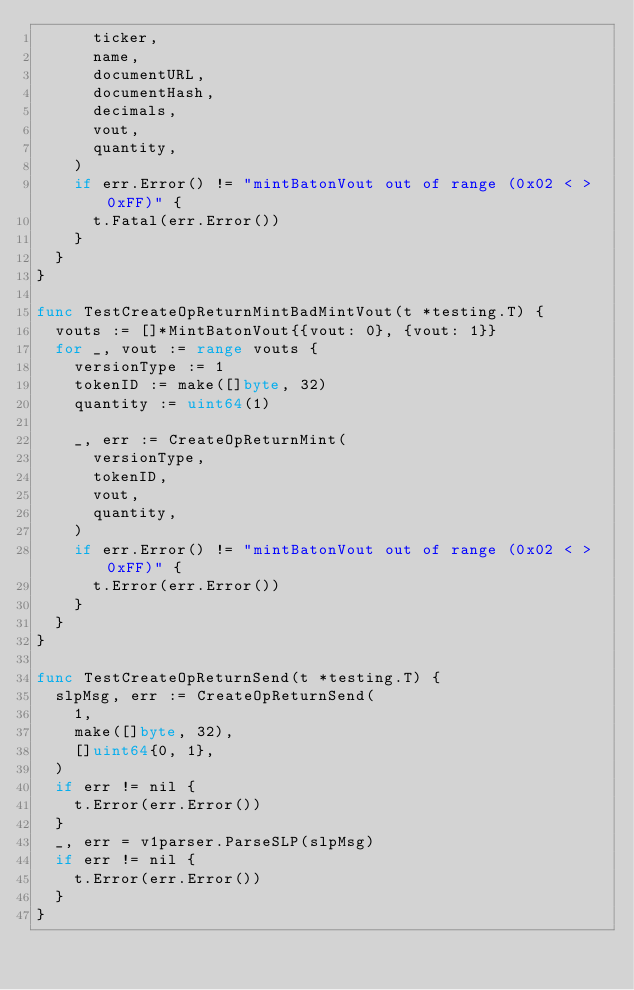Convert code to text. <code><loc_0><loc_0><loc_500><loc_500><_Go_>			ticker,
			name,
			documentURL,
			documentHash,
			decimals,
			vout,
			quantity,
		)
		if err.Error() != "mintBatonVout out of range (0x02 < > 0xFF)" {
			t.Fatal(err.Error())
		}
	}
}

func TestCreateOpReturnMintBadMintVout(t *testing.T) {
	vouts := []*MintBatonVout{{vout: 0}, {vout: 1}}
	for _, vout := range vouts {
		versionType := 1
		tokenID := make([]byte, 32)
		quantity := uint64(1)

		_, err := CreateOpReturnMint(
			versionType,
			tokenID,
			vout,
			quantity,
		)
		if err.Error() != "mintBatonVout out of range (0x02 < > 0xFF)" {
			t.Error(err.Error())
		}
	}
}

func TestCreateOpReturnSend(t *testing.T) {
	slpMsg, err := CreateOpReturnSend(
		1,
		make([]byte, 32),
		[]uint64{0, 1},
	)
	if err != nil {
		t.Error(err.Error())
	}
	_, err = v1parser.ParseSLP(slpMsg)
	if err != nil {
		t.Error(err.Error())
	}
}
</code> 